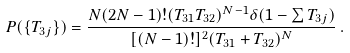<formula> <loc_0><loc_0><loc_500><loc_500>P ( \{ T _ { 3 j } \} ) = \frac { N ( 2 N - 1 ) ! ( T _ { 3 1 } T _ { 3 2 } ) ^ { N - 1 } \delta ( 1 - \sum T _ { 3 j } ) } { [ ( N - 1 ) ! ] ^ { 2 } ( T _ { 3 1 } + T _ { 3 2 } ) ^ { N } } \, .</formula> 